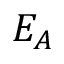<formula> <loc_0><loc_0><loc_500><loc_500>E _ { A }</formula> 